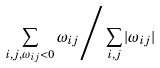<formula> <loc_0><loc_0><loc_500><loc_500>\sum _ { i , j , \omega _ { i j } < 0 } \omega _ { i j } \Big / \sum _ { i , j } | \omega _ { i j } |</formula> 